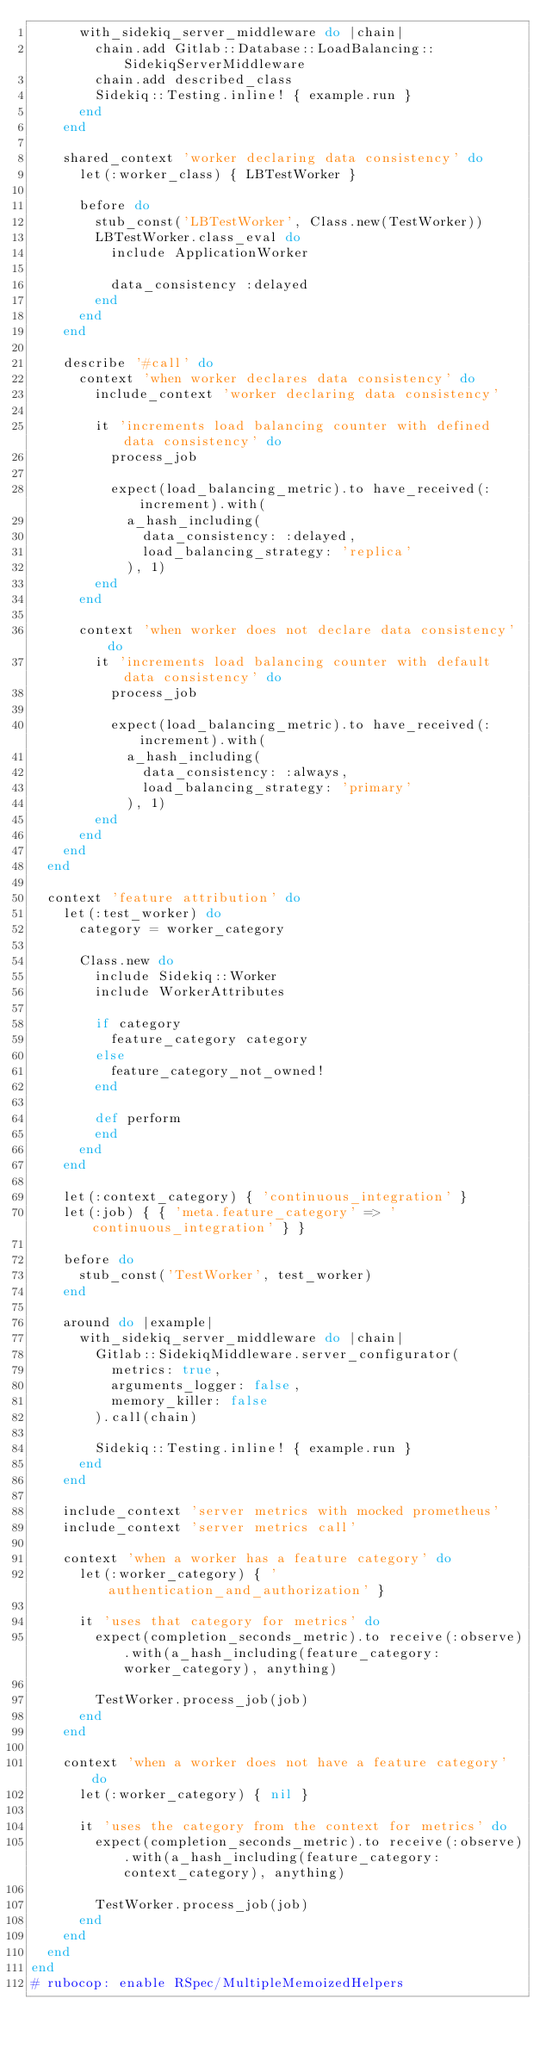<code> <loc_0><loc_0><loc_500><loc_500><_Ruby_>      with_sidekiq_server_middleware do |chain|
        chain.add Gitlab::Database::LoadBalancing::SidekiqServerMiddleware
        chain.add described_class
        Sidekiq::Testing.inline! { example.run }
      end
    end

    shared_context 'worker declaring data consistency' do
      let(:worker_class) { LBTestWorker }

      before do
        stub_const('LBTestWorker', Class.new(TestWorker))
        LBTestWorker.class_eval do
          include ApplicationWorker

          data_consistency :delayed
        end
      end
    end

    describe '#call' do
      context 'when worker declares data consistency' do
        include_context 'worker declaring data consistency'

        it 'increments load balancing counter with defined data consistency' do
          process_job

          expect(load_balancing_metric).to have_received(:increment).with(
            a_hash_including(
              data_consistency: :delayed,
              load_balancing_strategy: 'replica'
            ), 1)
        end
      end

      context 'when worker does not declare data consistency' do
        it 'increments load balancing counter with default data consistency' do
          process_job

          expect(load_balancing_metric).to have_received(:increment).with(
            a_hash_including(
              data_consistency: :always,
              load_balancing_strategy: 'primary'
            ), 1)
        end
      end
    end
  end

  context 'feature attribution' do
    let(:test_worker) do
      category = worker_category

      Class.new do
        include Sidekiq::Worker
        include WorkerAttributes

        if category
          feature_category category
        else
          feature_category_not_owned!
        end

        def perform
        end
      end
    end

    let(:context_category) { 'continuous_integration' }
    let(:job) { { 'meta.feature_category' => 'continuous_integration' } }

    before do
      stub_const('TestWorker', test_worker)
    end

    around do |example|
      with_sidekiq_server_middleware do |chain|
        Gitlab::SidekiqMiddleware.server_configurator(
          metrics: true,
          arguments_logger: false,
          memory_killer: false
        ).call(chain)

        Sidekiq::Testing.inline! { example.run }
      end
    end

    include_context 'server metrics with mocked prometheus'
    include_context 'server metrics call'

    context 'when a worker has a feature category' do
      let(:worker_category) { 'authentication_and_authorization' }

      it 'uses that category for metrics' do
        expect(completion_seconds_metric).to receive(:observe).with(a_hash_including(feature_category: worker_category), anything)

        TestWorker.process_job(job)
      end
    end

    context 'when a worker does not have a feature category' do
      let(:worker_category) { nil }

      it 'uses the category from the context for metrics' do
        expect(completion_seconds_metric).to receive(:observe).with(a_hash_including(feature_category: context_category), anything)

        TestWorker.process_job(job)
      end
    end
  end
end
# rubocop: enable RSpec/MultipleMemoizedHelpers
</code> 